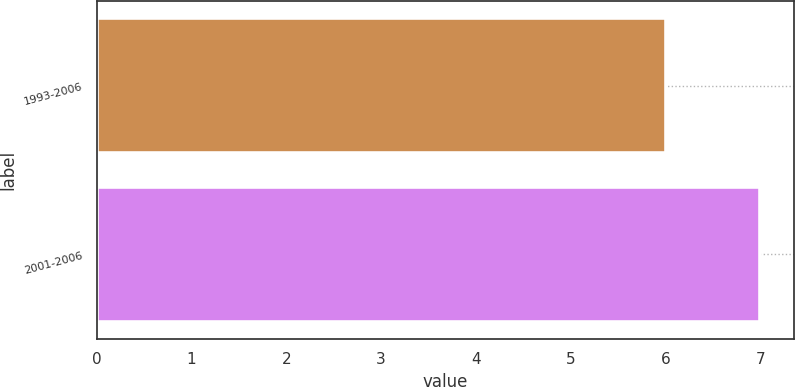Convert chart to OTSL. <chart><loc_0><loc_0><loc_500><loc_500><bar_chart><fcel>1993-2006<fcel>2001-2006<nl><fcel>6<fcel>7<nl></chart> 